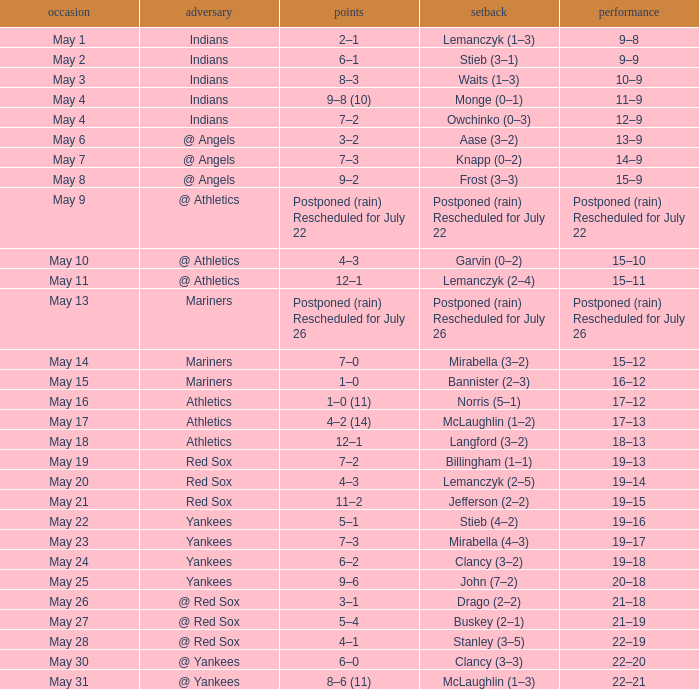Name the loss on may 22 Stieb (4–2). 